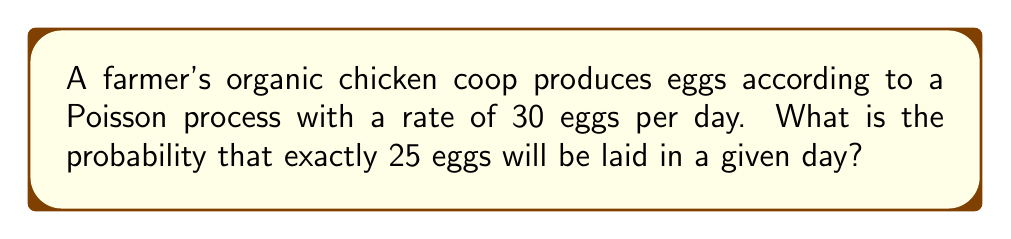Could you help me with this problem? To solve this problem, we'll use the Poisson distribution formula:

$$P(X = k) = \frac{e^{-\lambda} \lambda^k}{k!}$$

Where:
$\lambda$ = average rate of events (eggs laid per day) = 30
$k$ = number of events we're interested in = 25
$e$ = Euler's number ≈ 2.71828

Let's solve this step-by-step:

1) Substitute the values into the formula:

   $$P(X = 25) = \frac{e^{-30} 30^{25}}{25!}$$

2) Calculate $e^{-30}$:
   
   $e^{-30} \approx 9.357623 \times 10^{-14}$

3) Calculate $30^{25}$:
   
   $30^{25} \approx 3.725290 \times 10^{37}$

4) Calculate 25!:
   
   $25! = 15511210043330985984000000$

5) Put it all together:

   $$P(X = 25) = \frac{(9.357623 \times 10^{-14})(3.725290 \times 10^{37})}{15511210043330985984000000}$$

6) Simplify:

   $$P(X = 25) \approx 0.0516$$

Therefore, the probability of exactly 25 eggs being laid in a day is approximately 0.0516 or 5.16%.
Answer: 0.0516 